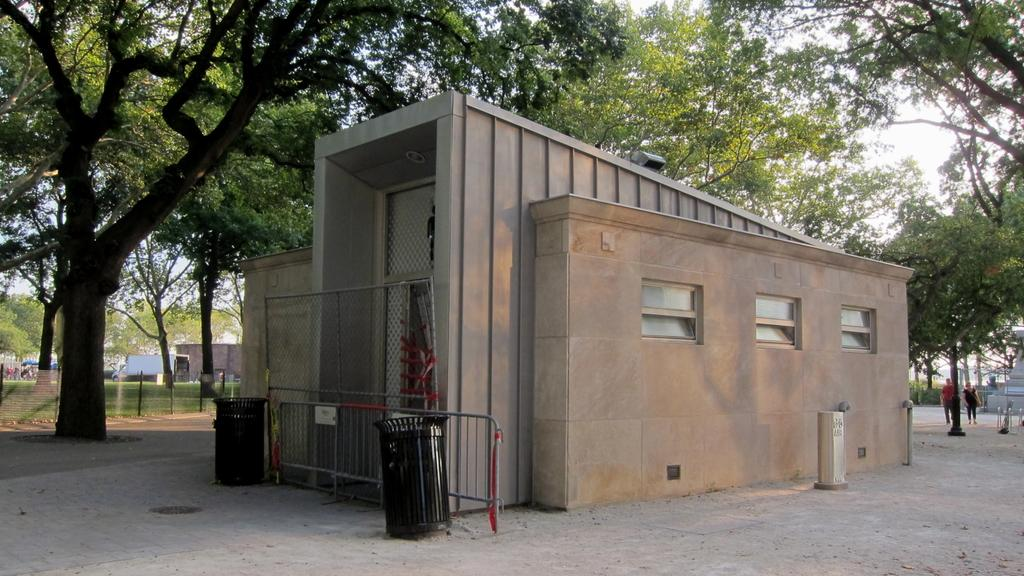What type of containers are present in the image? There are trash cans in the image. What object is used to catch or hold something in the image? There is a net in the image. What type of structure can be seen in the image? There is a building in the image. What are the people in the image doing? People are walking in the image. What type of barrier is present in the image? There is a fence in the image. What type of vegetation is present in the image? There are trees in the image. What type of temporary shelter is present in the image? There are tents in the image. What type of transportation is parked in the image? A vehicle is parked in the image. What can be seen in the background of the image? The sky is visible in the background of the image. What type of meal is being served in the image? There is no meal being served in the image. What type of bed is visible in the image? There is no bed present in the image. 